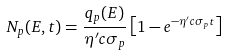<formula> <loc_0><loc_0><loc_500><loc_500>N _ { p } ( E , t ) = \frac { q _ { p } ( E ) } { \eta ^ { \prime } c \sigma _ { p } } \left [ 1 - e ^ { - \eta ^ { \prime } c \sigma _ { p } t } \right ]</formula> 